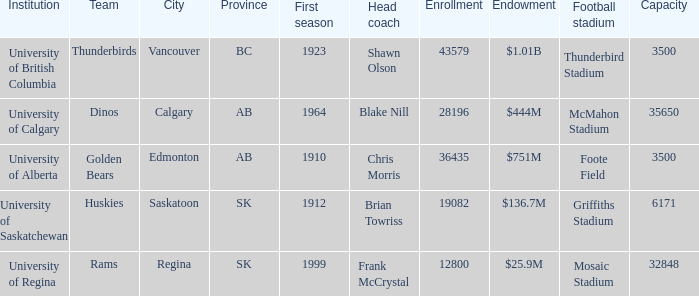What is the maximum number of participants allowed at foote field? 36435.0. 